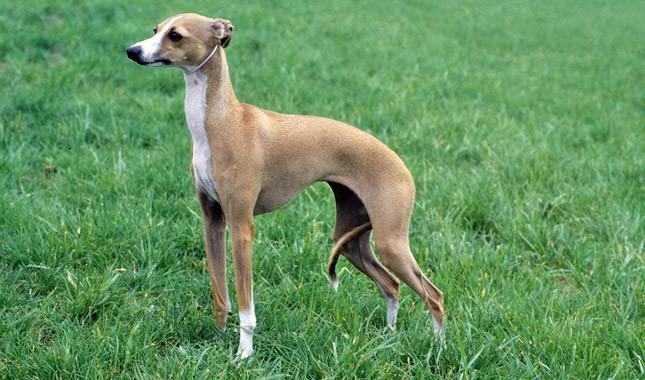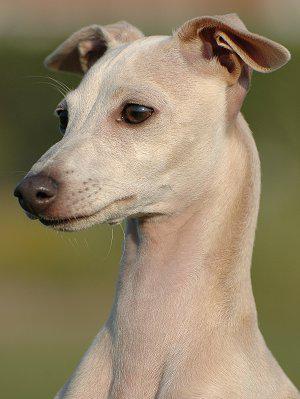The first image is the image on the left, the second image is the image on the right. Assess this claim about the two images: "Each dog is posed outside with its head facing forward, and each dog wears a type of collar.". Correct or not? Answer yes or no. No. The first image is the image on the left, the second image is the image on the right. Given the left and right images, does the statement "The dog in the left image is wearing a collar." hold true? Answer yes or no. No. 